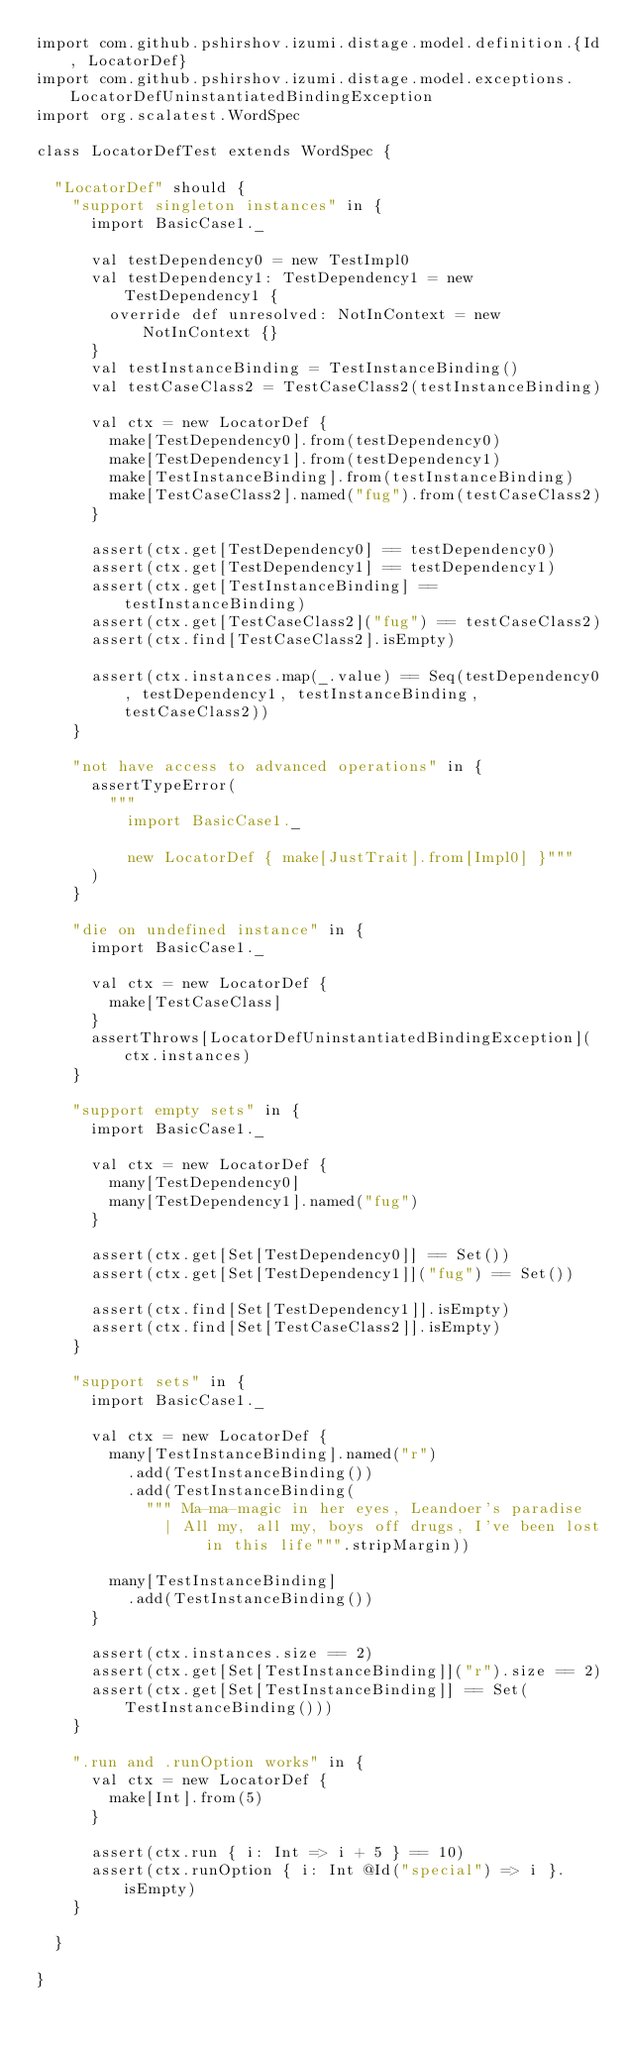Convert code to text. <code><loc_0><loc_0><loc_500><loc_500><_Scala_>import com.github.pshirshov.izumi.distage.model.definition.{Id, LocatorDef}
import com.github.pshirshov.izumi.distage.model.exceptions.LocatorDefUninstantiatedBindingException
import org.scalatest.WordSpec

class LocatorDefTest extends WordSpec {

  "LocatorDef" should {
    "support singleton instances" in {
      import BasicCase1._

      val testDependency0 = new TestImpl0
      val testDependency1: TestDependency1 = new TestDependency1 {
        override def unresolved: NotInContext = new NotInContext {}
      }
      val testInstanceBinding = TestInstanceBinding()
      val testCaseClass2 = TestCaseClass2(testInstanceBinding)

      val ctx = new LocatorDef {
        make[TestDependency0].from(testDependency0)
        make[TestDependency1].from(testDependency1)
        make[TestInstanceBinding].from(testInstanceBinding)
        make[TestCaseClass2].named("fug").from(testCaseClass2)
      }

      assert(ctx.get[TestDependency0] == testDependency0)
      assert(ctx.get[TestDependency1] == testDependency1)
      assert(ctx.get[TestInstanceBinding] == testInstanceBinding)
      assert(ctx.get[TestCaseClass2]("fug") == testCaseClass2)
      assert(ctx.find[TestCaseClass2].isEmpty)

      assert(ctx.instances.map(_.value) == Seq(testDependency0, testDependency1, testInstanceBinding, testCaseClass2))
    }

    "not have access to advanced operations" in {
      assertTypeError(
        """
          import BasicCase1._

          new LocatorDef { make[JustTrait].from[Impl0] }"""
      )
    }

    "die on undefined instance" in {
      import BasicCase1._

      val ctx = new LocatorDef {
        make[TestCaseClass]
      }
      assertThrows[LocatorDefUninstantiatedBindingException](ctx.instances)
    }

    "support empty sets" in {
      import BasicCase1._

      val ctx = new LocatorDef {
        many[TestDependency0]
        many[TestDependency1].named("fug")
      }

      assert(ctx.get[Set[TestDependency0]] == Set())
      assert(ctx.get[Set[TestDependency1]]("fug") == Set())

      assert(ctx.find[Set[TestDependency1]].isEmpty)
      assert(ctx.find[Set[TestCaseClass2]].isEmpty)
    }

    "support sets" in {
      import BasicCase1._

      val ctx = new LocatorDef {
        many[TestInstanceBinding].named("r")
          .add(TestInstanceBinding())
          .add(TestInstanceBinding(
            """ Ma-ma-magic in her eyes, Leandoer's paradise
              | All my, all my, boys off drugs, I've been lost in this life""".stripMargin))

        many[TestInstanceBinding]
          .add(TestInstanceBinding())
      }

      assert(ctx.instances.size == 2)
      assert(ctx.get[Set[TestInstanceBinding]]("r").size == 2)
      assert(ctx.get[Set[TestInstanceBinding]] == Set(TestInstanceBinding()))
    }

    ".run and .runOption works" in {
      val ctx = new LocatorDef {
        make[Int].from(5)
      }

      assert(ctx.run { i: Int => i + 5 } == 10)
      assert(ctx.runOption { i: Int @Id("special") => i }.isEmpty)
    }

  }

}
</code> 